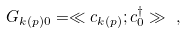<formula> <loc_0><loc_0><loc_500><loc_500>G _ { k ( p ) 0 } = \ll c _ { k ( p ) } ; c ^ { \dagger } _ { 0 } \gg \ ,</formula> 